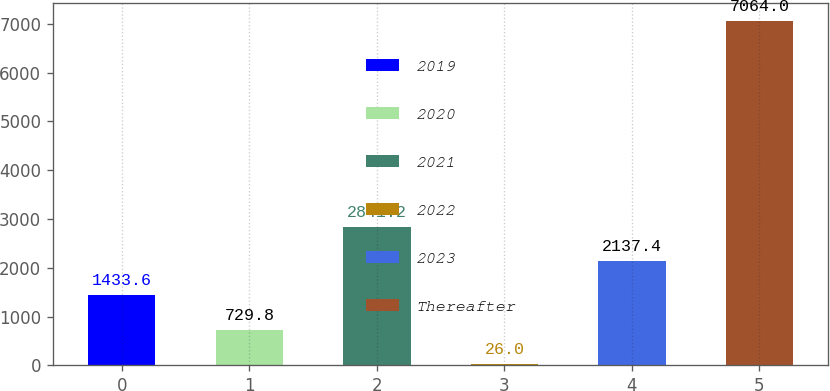Convert chart. <chart><loc_0><loc_0><loc_500><loc_500><bar_chart><fcel>2019<fcel>2020<fcel>2021<fcel>2022<fcel>2023<fcel>Thereafter<nl><fcel>1433.6<fcel>729.8<fcel>2841.2<fcel>26<fcel>2137.4<fcel>7064<nl></chart> 